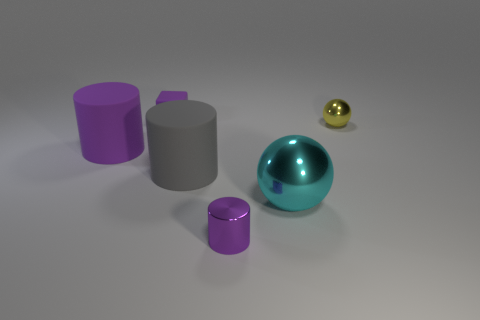Add 4 brown matte objects. How many objects exist? 10 Subtract all cubes. How many objects are left? 5 Add 6 gray cylinders. How many gray cylinders exist? 7 Subtract 0 green balls. How many objects are left? 6 Subtract all tiny brown metal cubes. Subtract all large gray things. How many objects are left? 5 Add 2 cyan metal balls. How many cyan metal balls are left? 3 